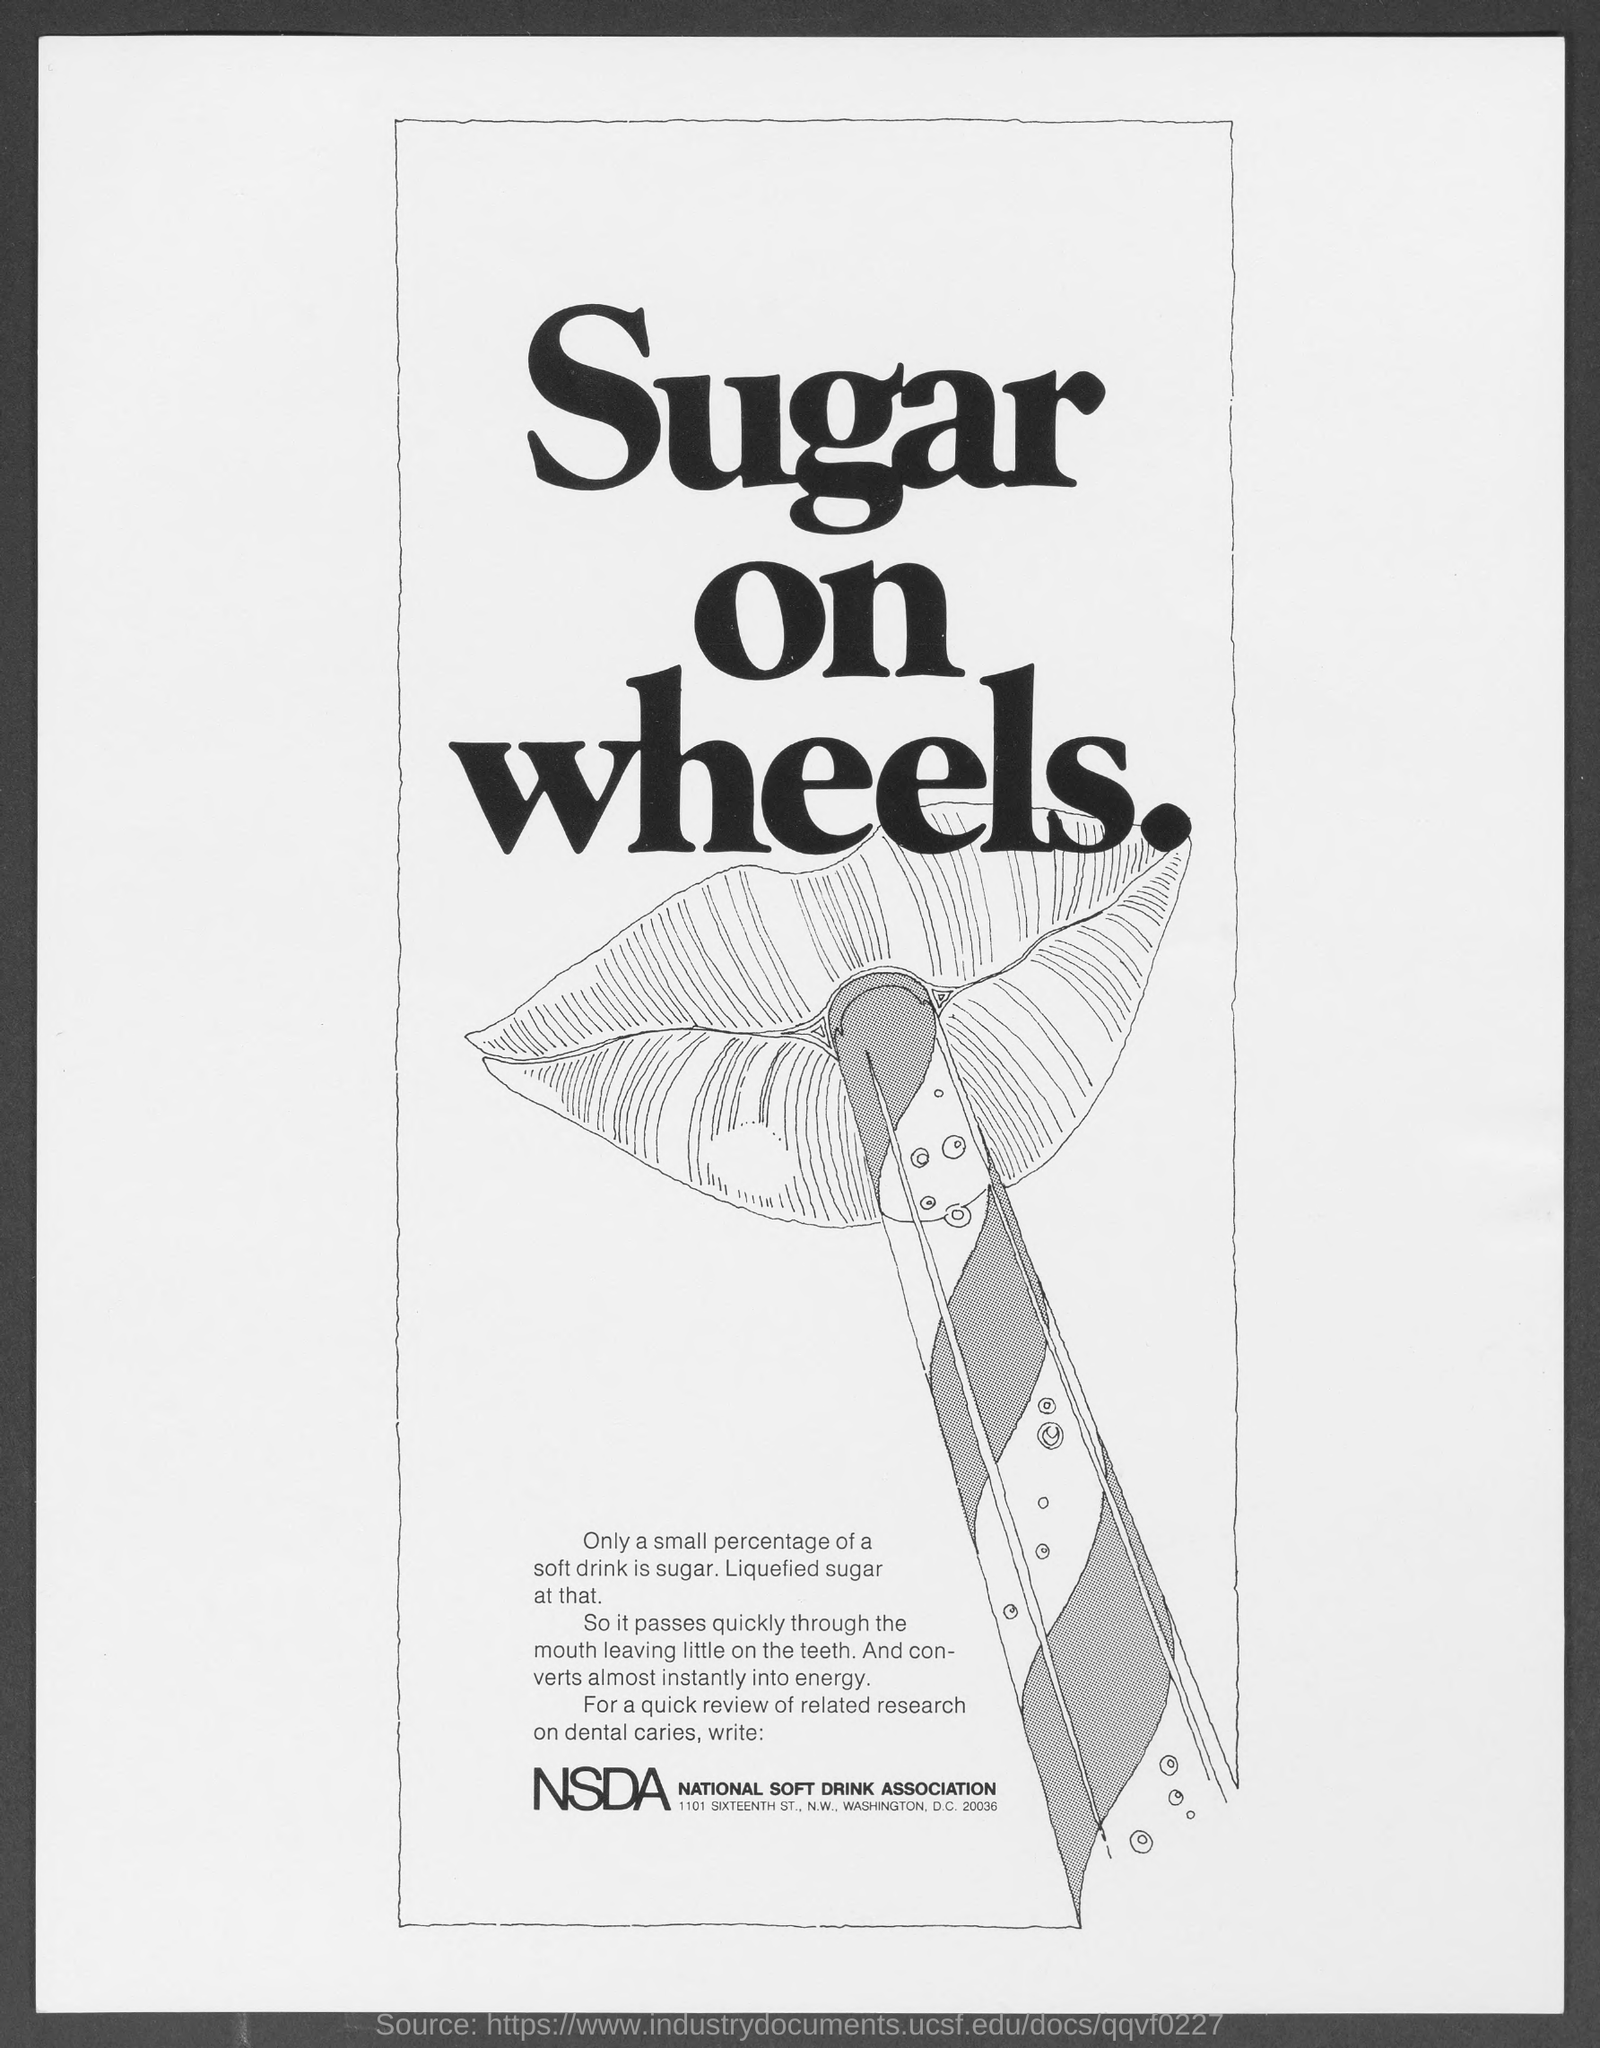List a handful of essential elements in this visual. The National Soft Drink Association (NSDA) is an organization that represents companies that produce and distribute soft drinks. 